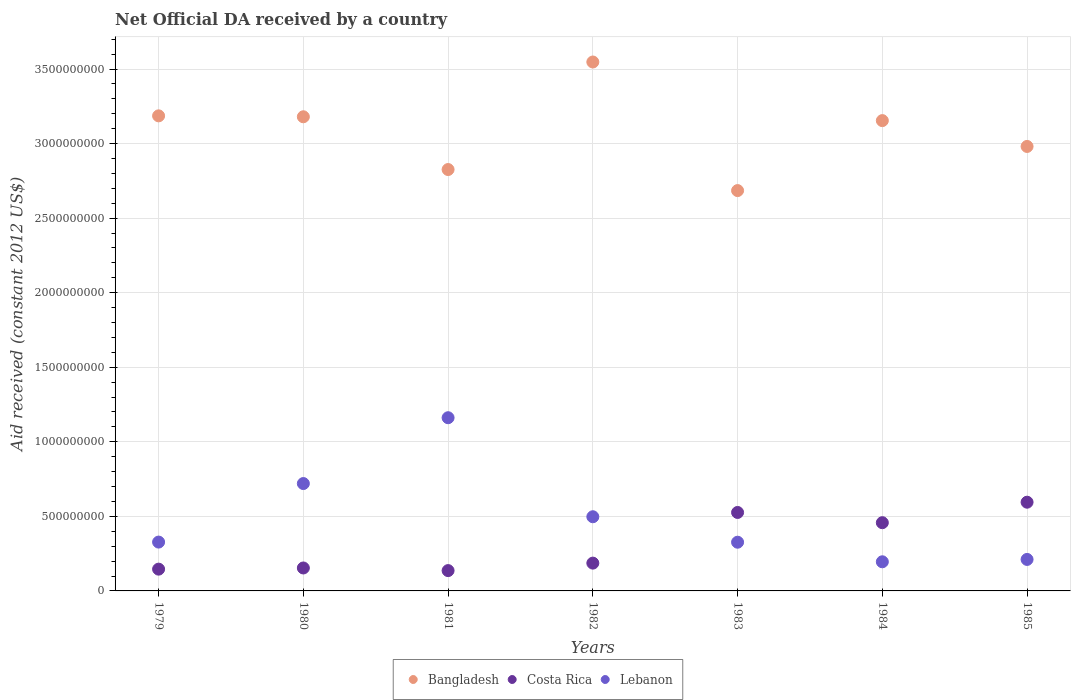How many different coloured dotlines are there?
Your response must be concise. 3. What is the net official development assistance aid received in Costa Rica in 1983?
Provide a succinct answer. 5.26e+08. Across all years, what is the maximum net official development assistance aid received in Lebanon?
Your answer should be compact. 1.16e+09. Across all years, what is the minimum net official development assistance aid received in Costa Rica?
Keep it short and to the point. 1.36e+08. In which year was the net official development assistance aid received in Bangladesh maximum?
Ensure brevity in your answer.  1982. What is the total net official development assistance aid received in Bangladesh in the graph?
Your response must be concise. 2.16e+1. What is the difference between the net official development assistance aid received in Bangladesh in 1980 and that in 1984?
Keep it short and to the point. 2.57e+07. What is the difference between the net official development assistance aid received in Costa Rica in 1979 and the net official development assistance aid received in Bangladesh in 1983?
Your answer should be compact. -2.54e+09. What is the average net official development assistance aid received in Costa Rica per year?
Make the answer very short. 3.14e+08. In the year 1983, what is the difference between the net official development assistance aid received in Lebanon and net official development assistance aid received in Costa Rica?
Provide a short and direct response. -2.00e+08. In how many years, is the net official development assistance aid received in Lebanon greater than 2300000000 US$?
Your answer should be compact. 0. What is the ratio of the net official development assistance aid received in Lebanon in 1982 to that in 1983?
Give a very brief answer. 1.52. Is the difference between the net official development assistance aid received in Lebanon in 1981 and 1985 greater than the difference between the net official development assistance aid received in Costa Rica in 1981 and 1985?
Give a very brief answer. Yes. What is the difference between the highest and the second highest net official development assistance aid received in Bangladesh?
Your answer should be compact. 3.61e+08. What is the difference between the highest and the lowest net official development assistance aid received in Bangladesh?
Offer a very short reply. 8.62e+08. In how many years, is the net official development assistance aid received in Lebanon greater than the average net official development assistance aid received in Lebanon taken over all years?
Offer a very short reply. 3. Is it the case that in every year, the sum of the net official development assistance aid received in Bangladesh and net official development assistance aid received in Costa Rica  is greater than the net official development assistance aid received in Lebanon?
Provide a succinct answer. Yes. Is the net official development assistance aid received in Lebanon strictly greater than the net official development assistance aid received in Bangladesh over the years?
Provide a succinct answer. No. How many dotlines are there?
Provide a short and direct response. 3. Where does the legend appear in the graph?
Make the answer very short. Bottom center. How are the legend labels stacked?
Offer a very short reply. Horizontal. What is the title of the graph?
Your answer should be compact. Net Official DA received by a country. What is the label or title of the Y-axis?
Provide a short and direct response. Aid received (constant 2012 US$). What is the Aid received (constant 2012 US$) of Bangladesh in 1979?
Your answer should be very brief. 3.19e+09. What is the Aid received (constant 2012 US$) in Costa Rica in 1979?
Give a very brief answer. 1.46e+08. What is the Aid received (constant 2012 US$) of Lebanon in 1979?
Give a very brief answer. 3.28e+08. What is the Aid received (constant 2012 US$) of Bangladesh in 1980?
Keep it short and to the point. 3.18e+09. What is the Aid received (constant 2012 US$) of Costa Rica in 1980?
Your answer should be very brief. 1.54e+08. What is the Aid received (constant 2012 US$) of Lebanon in 1980?
Give a very brief answer. 7.20e+08. What is the Aid received (constant 2012 US$) in Bangladesh in 1981?
Give a very brief answer. 2.83e+09. What is the Aid received (constant 2012 US$) of Costa Rica in 1981?
Offer a very short reply. 1.36e+08. What is the Aid received (constant 2012 US$) of Lebanon in 1981?
Make the answer very short. 1.16e+09. What is the Aid received (constant 2012 US$) of Bangladesh in 1982?
Keep it short and to the point. 3.55e+09. What is the Aid received (constant 2012 US$) of Costa Rica in 1982?
Ensure brevity in your answer.  1.86e+08. What is the Aid received (constant 2012 US$) of Lebanon in 1982?
Keep it short and to the point. 4.97e+08. What is the Aid received (constant 2012 US$) in Bangladesh in 1983?
Offer a very short reply. 2.68e+09. What is the Aid received (constant 2012 US$) in Costa Rica in 1983?
Make the answer very short. 5.26e+08. What is the Aid received (constant 2012 US$) in Lebanon in 1983?
Your answer should be very brief. 3.27e+08. What is the Aid received (constant 2012 US$) of Bangladesh in 1984?
Give a very brief answer. 3.15e+09. What is the Aid received (constant 2012 US$) of Costa Rica in 1984?
Provide a short and direct response. 4.58e+08. What is the Aid received (constant 2012 US$) in Lebanon in 1984?
Offer a terse response. 1.95e+08. What is the Aid received (constant 2012 US$) in Bangladesh in 1985?
Make the answer very short. 2.98e+09. What is the Aid received (constant 2012 US$) of Costa Rica in 1985?
Ensure brevity in your answer.  5.95e+08. What is the Aid received (constant 2012 US$) of Lebanon in 1985?
Your answer should be very brief. 2.11e+08. Across all years, what is the maximum Aid received (constant 2012 US$) in Bangladesh?
Offer a terse response. 3.55e+09. Across all years, what is the maximum Aid received (constant 2012 US$) in Costa Rica?
Give a very brief answer. 5.95e+08. Across all years, what is the maximum Aid received (constant 2012 US$) of Lebanon?
Give a very brief answer. 1.16e+09. Across all years, what is the minimum Aid received (constant 2012 US$) of Bangladesh?
Keep it short and to the point. 2.68e+09. Across all years, what is the minimum Aid received (constant 2012 US$) in Costa Rica?
Provide a succinct answer. 1.36e+08. Across all years, what is the minimum Aid received (constant 2012 US$) of Lebanon?
Offer a very short reply. 1.95e+08. What is the total Aid received (constant 2012 US$) in Bangladesh in the graph?
Offer a terse response. 2.16e+1. What is the total Aid received (constant 2012 US$) of Costa Rica in the graph?
Give a very brief answer. 2.20e+09. What is the total Aid received (constant 2012 US$) of Lebanon in the graph?
Keep it short and to the point. 3.44e+09. What is the difference between the Aid received (constant 2012 US$) in Bangladesh in 1979 and that in 1980?
Give a very brief answer. 6.20e+06. What is the difference between the Aid received (constant 2012 US$) in Costa Rica in 1979 and that in 1980?
Keep it short and to the point. -7.81e+06. What is the difference between the Aid received (constant 2012 US$) of Lebanon in 1979 and that in 1980?
Your response must be concise. -3.93e+08. What is the difference between the Aid received (constant 2012 US$) of Bangladesh in 1979 and that in 1981?
Your answer should be very brief. 3.60e+08. What is the difference between the Aid received (constant 2012 US$) in Costa Rica in 1979 and that in 1981?
Provide a succinct answer. 9.74e+06. What is the difference between the Aid received (constant 2012 US$) of Lebanon in 1979 and that in 1981?
Keep it short and to the point. -8.34e+08. What is the difference between the Aid received (constant 2012 US$) in Bangladesh in 1979 and that in 1982?
Provide a succinct answer. -3.61e+08. What is the difference between the Aid received (constant 2012 US$) in Costa Rica in 1979 and that in 1982?
Provide a succinct answer. -4.04e+07. What is the difference between the Aid received (constant 2012 US$) of Lebanon in 1979 and that in 1982?
Your answer should be very brief. -1.70e+08. What is the difference between the Aid received (constant 2012 US$) of Bangladesh in 1979 and that in 1983?
Keep it short and to the point. 5.01e+08. What is the difference between the Aid received (constant 2012 US$) in Costa Rica in 1979 and that in 1983?
Your response must be concise. -3.80e+08. What is the difference between the Aid received (constant 2012 US$) in Lebanon in 1979 and that in 1983?
Your answer should be compact. 8.50e+05. What is the difference between the Aid received (constant 2012 US$) in Bangladesh in 1979 and that in 1984?
Offer a very short reply. 3.19e+07. What is the difference between the Aid received (constant 2012 US$) of Costa Rica in 1979 and that in 1984?
Offer a very short reply. -3.12e+08. What is the difference between the Aid received (constant 2012 US$) of Lebanon in 1979 and that in 1984?
Keep it short and to the point. 1.32e+08. What is the difference between the Aid received (constant 2012 US$) in Bangladesh in 1979 and that in 1985?
Your response must be concise. 2.05e+08. What is the difference between the Aid received (constant 2012 US$) in Costa Rica in 1979 and that in 1985?
Your answer should be very brief. -4.49e+08. What is the difference between the Aid received (constant 2012 US$) of Lebanon in 1979 and that in 1985?
Provide a short and direct response. 1.16e+08. What is the difference between the Aid received (constant 2012 US$) in Bangladesh in 1980 and that in 1981?
Give a very brief answer. 3.54e+08. What is the difference between the Aid received (constant 2012 US$) in Costa Rica in 1980 and that in 1981?
Keep it short and to the point. 1.76e+07. What is the difference between the Aid received (constant 2012 US$) of Lebanon in 1980 and that in 1981?
Offer a terse response. -4.41e+08. What is the difference between the Aid received (constant 2012 US$) of Bangladesh in 1980 and that in 1982?
Ensure brevity in your answer.  -3.67e+08. What is the difference between the Aid received (constant 2012 US$) in Costa Rica in 1980 and that in 1982?
Provide a succinct answer. -3.26e+07. What is the difference between the Aid received (constant 2012 US$) of Lebanon in 1980 and that in 1982?
Your answer should be compact. 2.23e+08. What is the difference between the Aid received (constant 2012 US$) of Bangladesh in 1980 and that in 1983?
Provide a succinct answer. 4.95e+08. What is the difference between the Aid received (constant 2012 US$) in Costa Rica in 1980 and that in 1983?
Your response must be concise. -3.72e+08. What is the difference between the Aid received (constant 2012 US$) of Lebanon in 1980 and that in 1983?
Your answer should be compact. 3.93e+08. What is the difference between the Aid received (constant 2012 US$) of Bangladesh in 1980 and that in 1984?
Offer a terse response. 2.57e+07. What is the difference between the Aid received (constant 2012 US$) in Costa Rica in 1980 and that in 1984?
Offer a terse response. -3.04e+08. What is the difference between the Aid received (constant 2012 US$) in Lebanon in 1980 and that in 1984?
Offer a terse response. 5.25e+08. What is the difference between the Aid received (constant 2012 US$) in Bangladesh in 1980 and that in 1985?
Provide a succinct answer. 1.99e+08. What is the difference between the Aid received (constant 2012 US$) in Costa Rica in 1980 and that in 1985?
Your response must be concise. -4.41e+08. What is the difference between the Aid received (constant 2012 US$) of Lebanon in 1980 and that in 1985?
Offer a terse response. 5.09e+08. What is the difference between the Aid received (constant 2012 US$) of Bangladesh in 1981 and that in 1982?
Your answer should be compact. -7.21e+08. What is the difference between the Aid received (constant 2012 US$) of Costa Rica in 1981 and that in 1982?
Your response must be concise. -5.01e+07. What is the difference between the Aid received (constant 2012 US$) of Lebanon in 1981 and that in 1982?
Your answer should be compact. 6.64e+08. What is the difference between the Aid received (constant 2012 US$) of Bangladesh in 1981 and that in 1983?
Provide a succinct answer. 1.41e+08. What is the difference between the Aid received (constant 2012 US$) in Costa Rica in 1981 and that in 1983?
Your answer should be compact. -3.90e+08. What is the difference between the Aid received (constant 2012 US$) of Lebanon in 1981 and that in 1983?
Make the answer very short. 8.35e+08. What is the difference between the Aid received (constant 2012 US$) in Bangladesh in 1981 and that in 1984?
Your answer should be compact. -3.28e+08. What is the difference between the Aid received (constant 2012 US$) in Costa Rica in 1981 and that in 1984?
Give a very brief answer. -3.21e+08. What is the difference between the Aid received (constant 2012 US$) in Lebanon in 1981 and that in 1984?
Your answer should be compact. 9.66e+08. What is the difference between the Aid received (constant 2012 US$) of Bangladesh in 1981 and that in 1985?
Provide a succinct answer. -1.55e+08. What is the difference between the Aid received (constant 2012 US$) in Costa Rica in 1981 and that in 1985?
Keep it short and to the point. -4.59e+08. What is the difference between the Aid received (constant 2012 US$) of Lebanon in 1981 and that in 1985?
Keep it short and to the point. 9.50e+08. What is the difference between the Aid received (constant 2012 US$) in Bangladesh in 1982 and that in 1983?
Your answer should be compact. 8.62e+08. What is the difference between the Aid received (constant 2012 US$) in Costa Rica in 1982 and that in 1983?
Give a very brief answer. -3.40e+08. What is the difference between the Aid received (constant 2012 US$) of Lebanon in 1982 and that in 1983?
Your answer should be compact. 1.71e+08. What is the difference between the Aid received (constant 2012 US$) of Bangladesh in 1982 and that in 1984?
Offer a terse response. 3.93e+08. What is the difference between the Aid received (constant 2012 US$) of Costa Rica in 1982 and that in 1984?
Your answer should be compact. -2.71e+08. What is the difference between the Aid received (constant 2012 US$) in Lebanon in 1982 and that in 1984?
Make the answer very short. 3.02e+08. What is the difference between the Aid received (constant 2012 US$) of Bangladesh in 1982 and that in 1985?
Provide a succinct answer. 5.66e+08. What is the difference between the Aid received (constant 2012 US$) of Costa Rica in 1982 and that in 1985?
Provide a succinct answer. -4.09e+08. What is the difference between the Aid received (constant 2012 US$) of Lebanon in 1982 and that in 1985?
Provide a short and direct response. 2.86e+08. What is the difference between the Aid received (constant 2012 US$) of Bangladesh in 1983 and that in 1984?
Ensure brevity in your answer.  -4.69e+08. What is the difference between the Aid received (constant 2012 US$) of Costa Rica in 1983 and that in 1984?
Offer a very short reply. 6.86e+07. What is the difference between the Aid received (constant 2012 US$) of Lebanon in 1983 and that in 1984?
Your answer should be compact. 1.31e+08. What is the difference between the Aid received (constant 2012 US$) in Bangladesh in 1983 and that in 1985?
Ensure brevity in your answer.  -2.96e+08. What is the difference between the Aid received (constant 2012 US$) in Costa Rica in 1983 and that in 1985?
Your answer should be very brief. -6.88e+07. What is the difference between the Aid received (constant 2012 US$) of Lebanon in 1983 and that in 1985?
Provide a succinct answer. 1.16e+08. What is the difference between the Aid received (constant 2012 US$) of Bangladesh in 1984 and that in 1985?
Make the answer very short. 1.73e+08. What is the difference between the Aid received (constant 2012 US$) in Costa Rica in 1984 and that in 1985?
Ensure brevity in your answer.  -1.37e+08. What is the difference between the Aid received (constant 2012 US$) of Lebanon in 1984 and that in 1985?
Provide a succinct answer. -1.58e+07. What is the difference between the Aid received (constant 2012 US$) of Bangladesh in 1979 and the Aid received (constant 2012 US$) of Costa Rica in 1980?
Keep it short and to the point. 3.03e+09. What is the difference between the Aid received (constant 2012 US$) in Bangladesh in 1979 and the Aid received (constant 2012 US$) in Lebanon in 1980?
Your answer should be compact. 2.47e+09. What is the difference between the Aid received (constant 2012 US$) of Costa Rica in 1979 and the Aid received (constant 2012 US$) of Lebanon in 1980?
Give a very brief answer. -5.74e+08. What is the difference between the Aid received (constant 2012 US$) in Bangladesh in 1979 and the Aid received (constant 2012 US$) in Costa Rica in 1981?
Your answer should be very brief. 3.05e+09. What is the difference between the Aid received (constant 2012 US$) in Bangladesh in 1979 and the Aid received (constant 2012 US$) in Lebanon in 1981?
Offer a terse response. 2.02e+09. What is the difference between the Aid received (constant 2012 US$) in Costa Rica in 1979 and the Aid received (constant 2012 US$) in Lebanon in 1981?
Provide a succinct answer. -1.02e+09. What is the difference between the Aid received (constant 2012 US$) of Bangladesh in 1979 and the Aid received (constant 2012 US$) of Costa Rica in 1982?
Ensure brevity in your answer.  3.00e+09. What is the difference between the Aid received (constant 2012 US$) of Bangladesh in 1979 and the Aid received (constant 2012 US$) of Lebanon in 1982?
Your answer should be very brief. 2.69e+09. What is the difference between the Aid received (constant 2012 US$) in Costa Rica in 1979 and the Aid received (constant 2012 US$) in Lebanon in 1982?
Provide a short and direct response. -3.51e+08. What is the difference between the Aid received (constant 2012 US$) in Bangladesh in 1979 and the Aid received (constant 2012 US$) in Costa Rica in 1983?
Offer a terse response. 2.66e+09. What is the difference between the Aid received (constant 2012 US$) of Bangladesh in 1979 and the Aid received (constant 2012 US$) of Lebanon in 1983?
Keep it short and to the point. 2.86e+09. What is the difference between the Aid received (constant 2012 US$) in Costa Rica in 1979 and the Aid received (constant 2012 US$) in Lebanon in 1983?
Keep it short and to the point. -1.81e+08. What is the difference between the Aid received (constant 2012 US$) of Bangladesh in 1979 and the Aid received (constant 2012 US$) of Costa Rica in 1984?
Ensure brevity in your answer.  2.73e+09. What is the difference between the Aid received (constant 2012 US$) of Bangladesh in 1979 and the Aid received (constant 2012 US$) of Lebanon in 1984?
Your response must be concise. 2.99e+09. What is the difference between the Aid received (constant 2012 US$) in Costa Rica in 1979 and the Aid received (constant 2012 US$) in Lebanon in 1984?
Your response must be concise. -4.93e+07. What is the difference between the Aid received (constant 2012 US$) of Bangladesh in 1979 and the Aid received (constant 2012 US$) of Costa Rica in 1985?
Ensure brevity in your answer.  2.59e+09. What is the difference between the Aid received (constant 2012 US$) in Bangladesh in 1979 and the Aid received (constant 2012 US$) in Lebanon in 1985?
Give a very brief answer. 2.97e+09. What is the difference between the Aid received (constant 2012 US$) of Costa Rica in 1979 and the Aid received (constant 2012 US$) of Lebanon in 1985?
Make the answer very short. -6.51e+07. What is the difference between the Aid received (constant 2012 US$) in Bangladesh in 1980 and the Aid received (constant 2012 US$) in Costa Rica in 1981?
Keep it short and to the point. 3.04e+09. What is the difference between the Aid received (constant 2012 US$) in Bangladesh in 1980 and the Aid received (constant 2012 US$) in Lebanon in 1981?
Ensure brevity in your answer.  2.02e+09. What is the difference between the Aid received (constant 2012 US$) in Costa Rica in 1980 and the Aid received (constant 2012 US$) in Lebanon in 1981?
Provide a short and direct response. -1.01e+09. What is the difference between the Aid received (constant 2012 US$) of Bangladesh in 1980 and the Aid received (constant 2012 US$) of Costa Rica in 1982?
Your answer should be compact. 2.99e+09. What is the difference between the Aid received (constant 2012 US$) in Bangladesh in 1980 and the Aid received (constant 2012 US$) in Lebanon in 1982?
Provide a short and direct response. 2.68e+09. What is the difference between the Aid received (constant 2012 US$) in Costa Rica in 1980 and the Aid received (constant 2012 US$) in Lebanon in 1982?
Your answer should be compact. -3.44e+08. What is the difference between the Aid received (constant 2012 US$) of Bangladesh in 1980 and the Aid received (constant 2012 US$) of Costa Rica in 1983?
Give a very brief answer. 2.65e+09. What is the difference between the Aid received (constant 2012 US$) in Bangladesh in 1980 and the Aid received (constant 2012 US$) in Lebanon in 1983?
Provide a succinct answer. 2.85e+09. What is the difference between the Aid received (constant 2012 US$) in Costa Rica in 1980 and the Aid received (constant 2012 US$) in Lebanon in 1983?
Your response must be concise. -1.73e+08. What is the difference between the Aid received (constant 2012 US$) in Bangladesh in 1980 and the Aid received (constant 2012 US$) in Costa Rica in 1984?
Your answer should be compact. 2.72e+09. What is the difference between the Aid received (constant 2012 US$) of Bangladesh in 1980 and the Aid received (constant 2012 US$) of Lebanon in 1984?
Provide a succinct answer. 2.98e+09. What is the difference between the Aid received (constant 2012 US$) of Costa Rica in 1980 and the Aid received (constant 2012 US$) of Lebanon in 1984?
Provide a short and direct response. -4.15e+07. What is the difference between the Aid received (constant 2012 US$) of Bangladesh in 1980 and the Aid received (constant 2012 US$) of Costa Rica in 1985?
Your response must be concise. 2.58e+09. What is the difference between the Aid received (constant 2012 US$) in Bangladesh in 1980 and the Aid received (constant 2012 US$) in Lebanon in 1985?
Make the answer very short. 2.97e+09. What is the difference between the Aid received (constant 2012 US$) of Costa Rica in 1980 and the Aid received (constant 2012 US$) of Lebanon in 1985?
Offer a terse response. -5.73e+07. What is the difference between the Aid received (constant 2012 US$) of Bangladesh in 1981 and the Aid received (constant 2012 US$) of Costa Rica in 1982?
Your answer should be compact. 2.64e+09. What is the difference between the Aid received (constant 2012 US$) in Bangladesh in 1981 and the Aid received (constant 2012 US$) in Lebanon in 1982?
Ensure brevity in your answer.  2.33e+09. What is the difference between the Aid received (constant 2012 US$) in Costa Rica in 1981 and the Aid received (constant 2012 US$) in Lebanon in 1982?
Keep it short and to the point. -3.61e+08. What is the difference between the Aid received (constant 2012 US$) of Bangladesh in 1981 and the Aid received (constant 2012 US$) of Costa Rica in 1983?
Provide a short and direct response. 2.30e+09. What is the difference between the Aid received (constant 2012 US$) of Bangladesh in 1981 and the Aid received (constant 2012 US$) of Lebanon in 1983?
Provide a succinct answer. 2.50e+09. What is the difference between the Aid received (constant 2012 US$) of Costa Rica in 1981 and the Aid received (constant 2012 US$) of Lebanon in 1983?
Provide a short and direct response. -1.90e+08. What is the difference between the Aid received (constant 2012 US$) in Bangladesh in 1981 and the Aid received (constant 2012 US$) in Costa Rica in 1984?
Offer a terse response. 2.37e+09. What is the difference between the Aid received (constant 2012 US$) of Bangladesh in 1981 and the Aid received (constant 2012 US$) of Lebanon in 1984?
Give a very brief answer. 2.63e+09. What is the difference between the Aid received (constant 2012 US$) in Costa Rica in 1981 and the Aid received (constant 2012 US$) in Lebanon in 1984?
Your answer should be compact. -5.91e+07. What is the difference between the Aid received (constant 2012 US$) in Bangladesh in 1981 and the Aid received (constant 2012 US$) in Costa Rica in 1985?
Provide a succinct answer. 2.23e+09. What is the difference between the Aid received (constant 2012 US$) in Bangladesh in 1981 and the Aid received (constant 2012 US$) in Lebanon in 1985?
Keep it short and to the point. 2.61e+09. What is the difference between the Aid received (constant 2012 US$) of Costa Rica in 1981 and the Aid received (constant 2012 US$) of Lebanon in 1985?
Give a very brief answer. -7.49e+07. What is the difference between the Aid received (constant 2012 US$) of Bangladesh in 1982 and the Aid received (constant 2012 US$) of Costa Rica in 1983?
Your answer should be compact. 3.02e+09. What is the difference between the Aid received (constant 2012 US$) in Bangladesh in 1982 and the Aid received (constant 2012 US$) in Lebanon in 1983?
Offer a very short reply. 3.22e+09. What is the difference between the Aid received (constant 2012 US$) in Costa Rica in 1982 and the Aid received (constant 2012 US$) in Lebanon in 1983?
Provide a succinct answer. -1.40e+08. What is the difference between the Aid received (constant 2012 US$) in Bangladesh in 1982 and the Aid received (constant 2012 US$) in Costa Rica in 1984?
Provide a succinct answer. 3.09e+09. What is the difference between the Aid received (constant 2012 US$) of Bangladesh in 1982 and the Aid received (constant 2012 US$) of Lebanon in 1984?
Offer a terse response. 3.35e+09. What is the difference between the Aid received (constant 2012 US$) of Costa Rica in 1982 and the Aid received (constant 2012 US$) of Lebanon in 1984?
Offer a terse response. -8.94e+06. What is the difference between the Aid received (constant 2012 US$) in Bangladesh in 1982 and the Aid received (constant 2012 US$) in Costa Rica in 1985?
Offer a terse response. 2.95e+09. What is the difference between the Aid received (constant 2012 US$) in Bangladesh in 1982 and the Aid received (constant 2012 US$) in Lebanon in 1985?
Keep it short and to the point. 3.34e+09. What is the difference between the Aid received (constant 2012 US$) in Costa Rica in 1982 and the Aid received (constant 2012 US$) in Lebanon in 1985?
Your answer should be very brief. -2.48e+07. What is the difference between the Aid received (constant 2012 US$) in Bangladesh in 1983 and the Aid received (constant 2012 US$) in Costa Rica in 1984?
Your answer should be very brief. 2.23e+09. What is the difference between the Aid received (constant 2012 US$) in Bangladesh in 1983 and the Aid received (constant 2012 US$) in Lebanon in 1984?
Your answer should be compact. 2.49e+09. What is the difference between the Aid received (constant 2012 US$) of Costa Rica in 1983 and the Aid received (constant 2012 US$) of Lebanon in 1984?
Make the answer very short. 3.31e+08. What is the difference between the Aid received (constant 2012 US$) in Bangladesh in 1983 and the Aid received (constant 2012 US$) in Costa Rica in 1985?
Make the answer very short. 2.09e+09. What is the difference between the Aid received (constant 2012 US$) of Bangladesh in 1983 and the Aid received (constant 2012 US$) of Lebanon in 1985?
Offer a terse response. 2.47e+09. What is the difference between the Aid received (constant 2012 US$) of Costa Rica in 1983 and the Aid received (constant 2012 US$) of Lebanon in 1985?
Give a very brief answer. 3.15e+08. What is the difference between the Aid received (constant 2012 US$) in Bangladesh in 1984 and the Aid received (constant 2012 US$) in Costa Rica in 1985?
Your answer should be compact. 2.56e+09. What is the difference between the Aid received (constant 2012 US$) in Bangladesh in 1984 and the Aid received (constant 2012 US$) in Lebanon in 1985?
Your response must be concise. 2.94e+09. What is the difference between the Aid received (constant 2012 US$) in Costa Rica in 1984 and the Aid received (constant 2012 US$) in Lebanon in 1985?
Your response must be concise. 2.46e+08. What is the average Aid received (constant 2012 US$) in Bangladesh per year?
Make the answer very short. 3.08e+09. What is the average Aid received (constant 2012 US$) of Costa Rica per year?
Offer a terse response. 3.14e+08. What is the average Aid received (constant 2012 US$) in Lebanon per year?
Offer a terse response. 4.91e+08. In the year 1979, what is the difference between the Aid received (constant 2012 US$) of Bangladesh and Aid received (constant 2012 US$) of Costa Rica?
Provide a short and direct response. 3.04e+09. In the year 1979, what is the difference between the Aid received (constant 2012 US$) in Bangladesh and Aid received (constant 2012 US$) in Lebanon?
Give a very brief answer. 2.86e+09. In the year 1979, what is the difference between the Aid received (constant 2012 US$) of Costa Rica and Aid received (constant 2012 US$) of Lebanon?
Offer a very short reply. -1.81e+08. In the year 1980, what is the difference between the Aid received (constant 2012 US$) of Bangladesh and Aid received (constant 2012 US$) of Costa Rica?
Give a very brief answer. 3.03e+09. In the year 1980, what is the difference between the Aid received (constant 2012 US$) in Bangladesh and Aid received (constant 2012 US$) in Lebanon?
Offer a terse response. 2.46e+09. In the year 1980, what is the difference between the Aid received (constant 2012 US$) of Costa Rica and Aid received (constant 2012 US$) of Lebanon?
Ensure brevity in your answer.  -5.66e+08. In the year 1981, what is the difference between the Aid received (constant 2012 US$) in Bangladesh and Aid received (constant 2012 US$) in Costa Rica?
Make the answer very short. 2.69e+09. In the year 1981, what is the difference between the Aid received (constant 2012 US$) of Bangladesh and Aid received (constant 2012 US$) of Lebanon?
Make the answer very short. 1.66e+09. In the year 1981, what is the difference between the Aid received (constant 2012 US$) of Costa Rica and Aid received (constant 2012 US$) of Lebanon?
Your response must be concise. -1.03e+09. In the year 1982, what is the difference between the Aid received (constant 2012 US$) of Bangladesh and Aid received (constant 2012 US$) of Costa Rica?
Make the answer very short. 3.36e+09. In the year 1982, what is the difference between the Aid received (constant 2012 US$) of Bangladesh and Aid received (constant 2012 US$) of Lebanon?
Ensure brevity in your answer.  3.05e+09. In the year 1982, what is the difference between the Aid received (constant 2012 US$) in Costa Rica and Aid received (constant 2012 US$) in Lebanon?
Provide a succinct answer. -3.11e+08. In the year 1983, what is the difference between the Aid received (constant 2012 US$) in Bangladesh and Aid received (constant 2012 US$) in Costa Rica?
Your answer should be very brief. 2.16e+09. In the year 1983, what is the difference between the Aid received (constant 2012 US$) of Bangladesh and Aid received (constant 2012 US$) of Lebanon?
Ensure brevity in your answer.  2.36e+09. In the year 1983, what is the difference between the Aid received (constant 2012 US$) of Costa Rica and Aid received (constant 2012 US$) of Lebanon?
Your answer should be compact. 2.00e+08. In the year 1984, what is the difference between the Aid received (constant 2012 US$) in Bangladesh and Aid received (constant 2012 US$) in Costa Rica?
Keep it short and to the point. 2.70e+09. In the year 1984, what is the difference between the Aid received (constant 2012 US$) in Bangladesh and Aid received (constant 2012 US$) in Lebanon?
Your answer should be very brief. 2.96e+09. In the year 1984, what is the difference between the Aid received (constant 2012 US$) of Costa Rica and Aid received (constant 2012 US$) of Lebanon?
Ensure brevity in your answer.  2.62e+08. In the year 1985, what is the difference between the Aid received (constant 2012 US$) of Bangladesh and Aid received (constant 2012 US$) of Costa Rica?
Provide a short and direct response. 2.39e+09. In the year 1985, what is the difference between the Aid received (constant 2012 US$) in Bangladesh and Aid received (constant 2012 US$) in Lebanon?
Offer a terse response. 2.77e+09. In the year 1985, what is the difference between the Aid received (constant 2012 US$) in Costa Rica and Aid received (constant 2012 US$) in Lebanon?
Provide a succinct answer. 3.84e+08. What is the ratio of the Aid received (constant 2012 US$) in Costa Rica in 1979 to that in 1980?
Keep it short and to the point. 0.95. What is the ratio of the Aid received (constant 2012 US$) in Lebanon in 1979 to that in 1980?
Provide a short and direct response. 0.45. What is the ratio of the Aid received (constant 2012 US$) in Bangladesh in 1979 to that in 1981?
Your answer should be compact. 1.13. What is the ratio of the Aid received (constant 2012 US$) in Costa Rica in 1979 to that in 1981?
Keep it short and to the point. 1.07. What is the ratio of the Aid received (constant 2012 US$) of Lebanon in 1979 to that in 1981?
Offer a terse response. 0.28. What is the ratio of the Aid received (constant 2012 US$) in Bangladesh in 1979 to that in 1982?
Offer a terse response. 0.9. What is the ratio of the Aid received (constant 2012 US$) of Costa Rica in 1979 to that in 1982?
Offer a very short reply. 0.78. What is the ratio of the Aid received (constant 2012 US$) of Lebanon in 1979 to that in 1982?
Offer a very short reply. 0.66. What is the ratio of the Aid received (constant 2012 US$) of Bangladesh in 1979 to that in 1983?
Make the answer very short. 1.19. What is the ratio of the Aid received (constant 2012 US$) in Costa Rica in 1979 to that in 1983?
Keep it short and to the point. 0.28. What is the ratio of the Aid received (constant 2012 US$) in Costa Rica in 1979 to that in 1984?
Offer a very short reply. 0.32. What is the ratio of the Aid received (constant 2012 US$) of Lebanon in 1979 to that in 1984?
Offer a terse response. 1.68. What is the ratio of the Aid received (constant 2012 US$) in Bangladesh in 1979 to that in 1985?
Your answer should be very brief. 1.07. What is the ratio of the Aid received (constant 2012 US$) of Costa Rica in 1979 to that in 1985?
Provide a short and direct response. 0.25. What is the ratio of the Aid received (constant 2012 US$) of Lebanon in 1979 to that in 1985?
Give a very brief answer. 1.55. What is the ratio of the Aid received (constant 2012 US$) in Bangladesh in 1980 to that in 1981?
Your response must be concise. 1.13. What is the ratio of the Aid received (constant 2012 US$) in Costa Rica in 1980 to that in 1981?
Keep it short and to the point. 1.13. What is the ratio of the Aid received (constant 2012 US$) in Lebanon in 1980 to that in 1981?
Keep it short and to the point. 0.62. What is the ratio of the Aid received (constant 2012 US$) of Bangladesh in 1980 to that in 1982?
Your answer should be compact. 0.9. What is the ratio of the Aid received (constant 2012 US$) of Costa Rica in 1980 to that in 1982?
Your response must be concise. 0.83. What is the ratio of the Aid received (constant 2012 US$) in Lebanon in 1980 to that in 1982?
Your answer should be very brief. 1.45. What is the ratio of the Aid received (constant 2012 US$) of Bangladesh in 1980 to that in 1983?
Provide a succinct answer. 1.18. What is the ratio of the Aid received (constant 2012 US$) of Costa Rica in 1980 to that in 1983?
Offer a terse response. 0.29. What is the ratio of the Aid received (constant 2012 US$) in Lebanon in 1980 to that in 1983?
Offer a terse response. 2.2. What is the ratio of the Aid received (constant 2012 US$) of Bangladesh in 1980 to that in 1984?
Offer a very short reply. 1.01. What is the ratio of the Aid received (constant 2012 US$) in Costa Rica in 1980 to that in 1984?
Your answer should be very brief. 0.34. What is the ratio of the Aid received (constant 2012 US$) of Lebanon in 1980 to that in 1984?
Offer a very short reply. 3.69. What is the ratio of the Aid received (constant 2012 US$) in Bangladesh in 1980 to that in 1985?
Your answer should be compact. 1.07. What is the ratio of the Aid received (constant 2012 US$) of Costa Rica in 1980 to that in 1985?
Your response must be concise. 0.26. What is the ratio of the Aid received (constant 2012 US$) in Lebanon in 1980 to that in 1985?
Ensure brevity in your answer.  3.41. What is the ratio of the Aid received (constant 2012 US$) in Bangladesh in 1981 to that in 1982?
Your answer should be compact. 0.8. What is the ratio of the Aid received (constant 2012 US$) of Costa Rica in 1981 to that in 1982?
Your response must be concise. 0.73. What is the ratio of the Aid received (constant 2012 US$) in Lebanon in 1981 to that in 1982?
Keep it short and to the point. 2.33. What is the ratio of the Aid received (constant 2012 US$) in Bangladesh in 1981 to that in 1983?
Provide a succinct answer. 1.05. What is the ratio of the Aid received (constant 2012 US$) in Costa Rica in 1981 to that in 1983?
Offer a very short reply. 0.26. What is the ratio of the Aid received (constant 2012 US$) in Lebanon in 1981 to that in 1983?
Your response must be concise. 3.56. What is the ratio of the Aid received (constant 2012 US$) in Bangladesh in 1981 to that in 1984?
Your answer should be very brief. 0.9. What is the ratio of the Aid received (constant 2012 US$) of Costa Rica in 1981 to that in 1984?
Your answer should be compact. 0.3. What is the ratio of the Aid received (constant 2012 US$) of Lebanon in 1981 to that in 1984?
Give a very brief answer. 5.95. What is the ratio of the Aid received (constant 2012 US$) in Bangladesh in 1981 to that in 1985?
Offer a very short reply. 0.95. What is the ratio of the Aid received (constant 2012 US$) in Costa Rica in 1981 to that in 1985?
Keep it short and to the point. 0.23. What is the ratio of the Aid received (constant 2012 US$) in Lebanon in 1981 to that in 1985?
Offer a very short reply. 5.5. What is the ratio of the Aid received (constant 2012 US$) in Bangladesh in 1982 to that in 1983?
Offer a terse response. 1.32. What is the ratio of the Aid received (constant 2012 US$) in Costa Rica in 1982 to that in 1983?
Make the answer very short. 0.35. What is the ratio of the Aid received (constant 2012 US$) of Lebanon in 1982 to that in 1983?
Give a very brief answer. 1.52. What is the ratio of the Aid received (constant 2012 US$) of Bangladesh in 1982 to that in 1984?
Ensure brevity in your answer.  1.12. What is the ratio of the Aid received (constant 2012 US$) of Costa Rica in 1982 to that in 1984?
Provide a short and direct response. 0.41. What is the ratio of the Aid received (constant 2012 US$) of Lebanon in 1982 to that in 1984?
Your answer should be very brief. 2.55. What is the ratio of the Aid received (constant 2012 US$) of Bangladesh in 1982 to that in 1985?
Give a very brief answer. 1.19. What is the ratio of the Aid received (constant 2012 US$) of Costa Rica in 1982 to that in 1985?
Give a very brief answer. 0.31. What is the ratio of the Aid received (constant 2012 US$) of Lebanon in 1982 to that in 1985?
Offer a terse response. 2.36. What is the ratio of the Aid received (constant 2012 US$) of Bangladesh in 1983 to that in 1984?
Ensure brevity in your answer.  0.85. What is the ratio of the Aid received (constant 2012 US$) in Costa Rica in 1983 to that in 1984?
Provide a succinct answer. 1.15. What is the ratio of the Aid received (constant 2012 US$) of Lebanon in 1983 to that in 1984?
Provide a short and direct response. 1.67. What is the ratio of the Aid received (constant 2012 US$) of Bangladesh in 1983 to that in 1985?
Provide a short and direct response. 0.9. What is the ratio of the Aid received (constant 2012 US$) of Costa Rica in 1983 to that in 1985?
Offer a terse response. 0.88. What is the ratio of the Aid received (constant 2012 US$) of Lebanon in 1983 to that in 1985?
Offer a very short reply. 1.55. What is the ratio of the Aid received (constant 2012 US$) in Bangladesh in 1984 to that in 1985?
Make the answer very short. 1.06. What is the ratio of the Aid received (constant 2012 US$) of Costa Rica in 1984 to that in 1985?
Make the answer very short. 0.77. What is the ratio of the Aid received (constant 2012 US$) in Lebanon in 1984 to that in 1985?
Provide a short and direct response. 0.93. What is the difference between the highest and the second highest Aid received (constant 2012 US$) of Bangladesh?
Offer a terse response. 3.61e+08. What is the difference between the highest and the second highest Aid received (constant 2012 US$) of Costa Rica?
Provide a short and direct response. 6.88e+07. What is the difference between the highest and the second highest Aid received (constant 2012 US$) of Lebanon?
Keep it short and to the point. 4.41e+08. What is the difference between the highest and the lowest Aid received (constant 2012 US$) in Bangladesh?
Keep it short and to the point. 8.62e+08. What is the difference between the highest and the lowest Aid received (constant 2012 US$) in Costa Rica?
Keep it short and to the point. 4.59e+08. What is the difference between the highest and the lowest Aid received (constant 2012 US$) in Lebanon?
Give a very brief answer. 9.66e+08. 